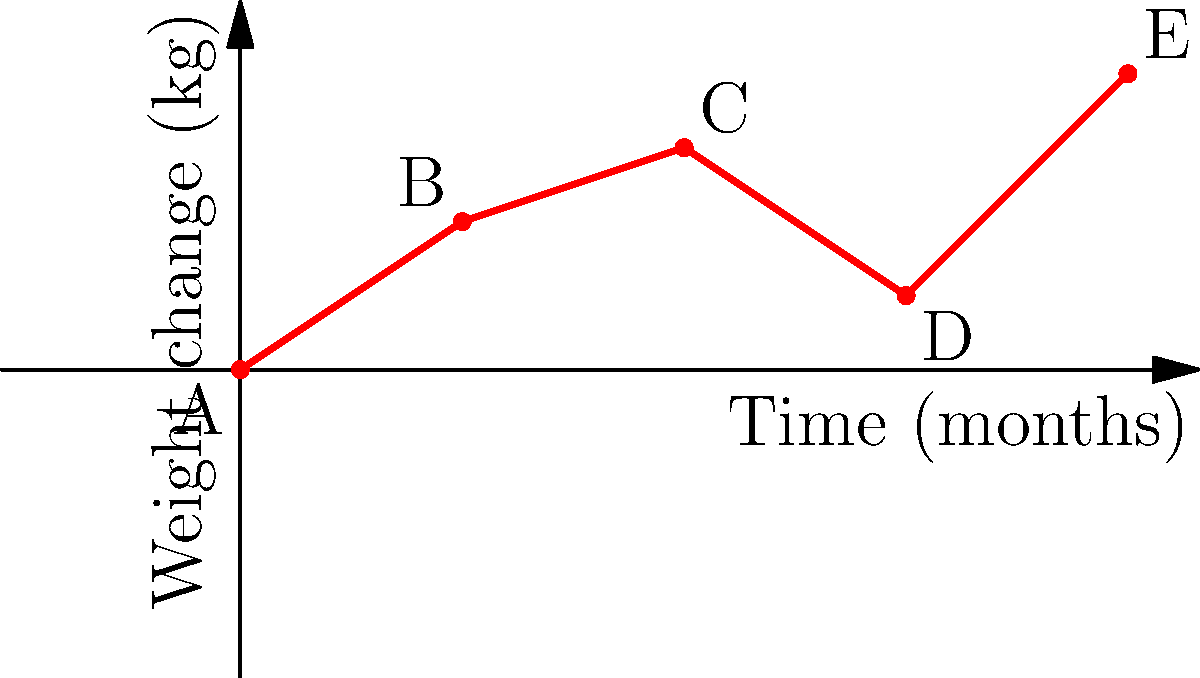The graph shows a child's weight change over a year, measured every three months. Points A, B, C, D, and E represent the cumulative weight change at 0, 3, 6, 9, and 12 months, respectively. Using vector addition, calculate the total weight change vector from point A to point E. To solve this problem, we'll use vector addition to find the total weight change vector from A to E. We'll break it down step-by-step:

1) First, let's define the vectors between each consecutive point:
   $\vec{AB} = (3, 2)$
   $\vec{BC} = (3, 1)$
   $\vec{CD} = (3, -2)$
   $\vec{DE} = (3, 3)$

2) The total weight change vector $\vec{AE}$ is the sum of these vectors:
   $\vec{AE} = \vec{AB} + \vec{BC} + \vec{CD} + \vec{DE}$

3) Let's add the x-components and y-components separately:
   x-component: $3 + 3 + 3 + 3 = 12$ months
   y-component: $2 + 1 + (-2) + 3 = 4$ kg

4) Therefore, the total weight change vector is:
   $\vec{AE} = (12, 4)$

This vector represents a total time period of 12 months and a total weight change of 4 kg.
Answer: $(12, 4)$ 